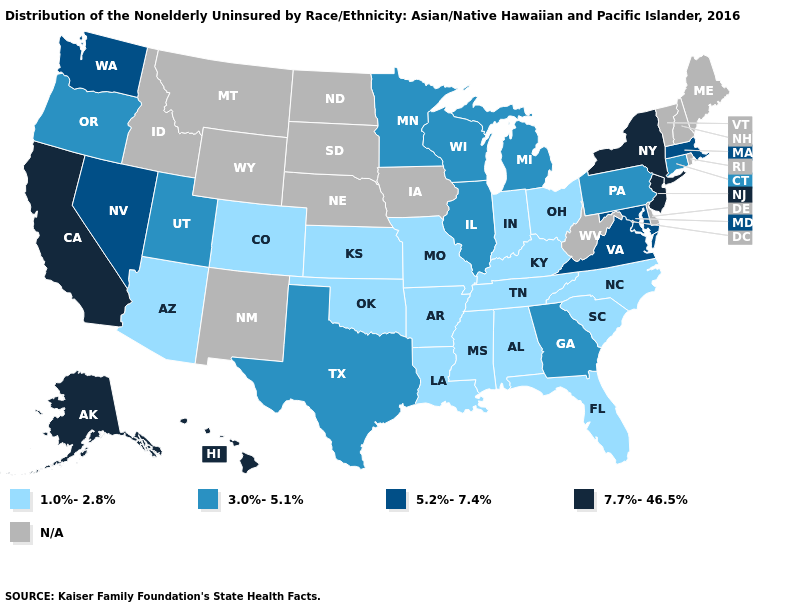Among the states that border Wyoming , does Colorado have the lowest value?
Be succinct. Yes. Which states hav the highest value in the MidWest?
Concise answer only. Illinois, Michigan, Minnesota, Wisconsin. Name the states that have a value in the range 1.0%-2.8%?
Concise answer only. Alabama, Arizona, Arkansas, Colorado, Florida, Indiana, Kansas, Kentucky, Louisiana, Mississippi, Missouri, North Carolina, Ohio, Oklahoma, South Carolina, Tennessee. What is the value of Iowa?
Concise answer only. N/A. Which states hav the highest value in the West?
Concise answer only. Alaska, California, Hawaii. What is the value of New Jersey?
Quick response, please. 7.7%-46.5%. Name the states that have a value in the range 3.0%-5.1%?
Short answer required. Connecticut, Georgia, Illinois, Michigan, Minnesota, Oregon, Pennsylvania, Texas, Utah, Wisconsin. Does the map have missing data?
Concise answer only. Yes. Name the states that have a value in the range N/A?
Answer briefly. Delaware, Idaho, Iowa, Maine, Montana, Nebraska, New Hampshire, New Mexico, North Dakota, Rhode Island, South Dakota, Vermont, West Virginia, Wyoming. Among the states that border Utah , does Nevada have the highest value?
Be succinct. Yes. What is the lowest value in the Northeast?
Quick response, please. 3.0%-5.1%. What is the lowest value in the MidWest?
Be succinct. 1.0%-2.8%. Does Texas have the highest value in the USA?
Quick response, please. No. 